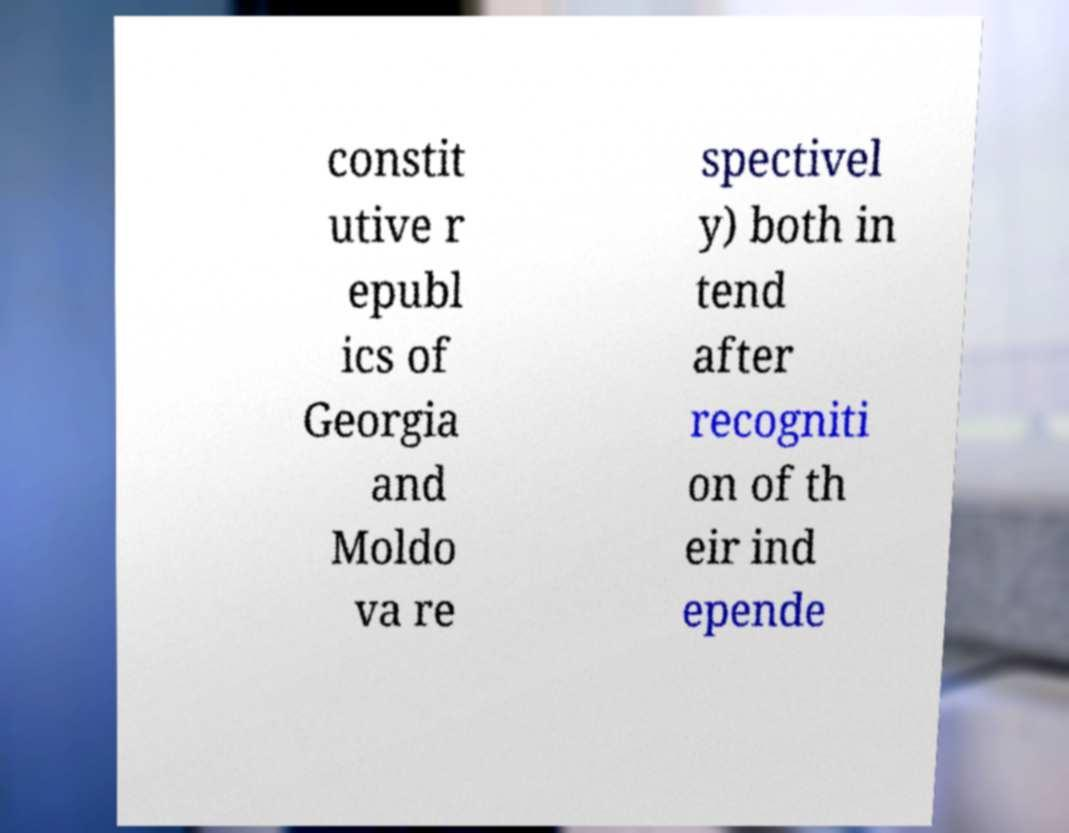What messages or text are displayed in this image? I need them in a readable, typed format. constit utive r epubl ics of Georgia and Moldo va re spectivel y) both in tend after recogniti on of th eir ind epende 